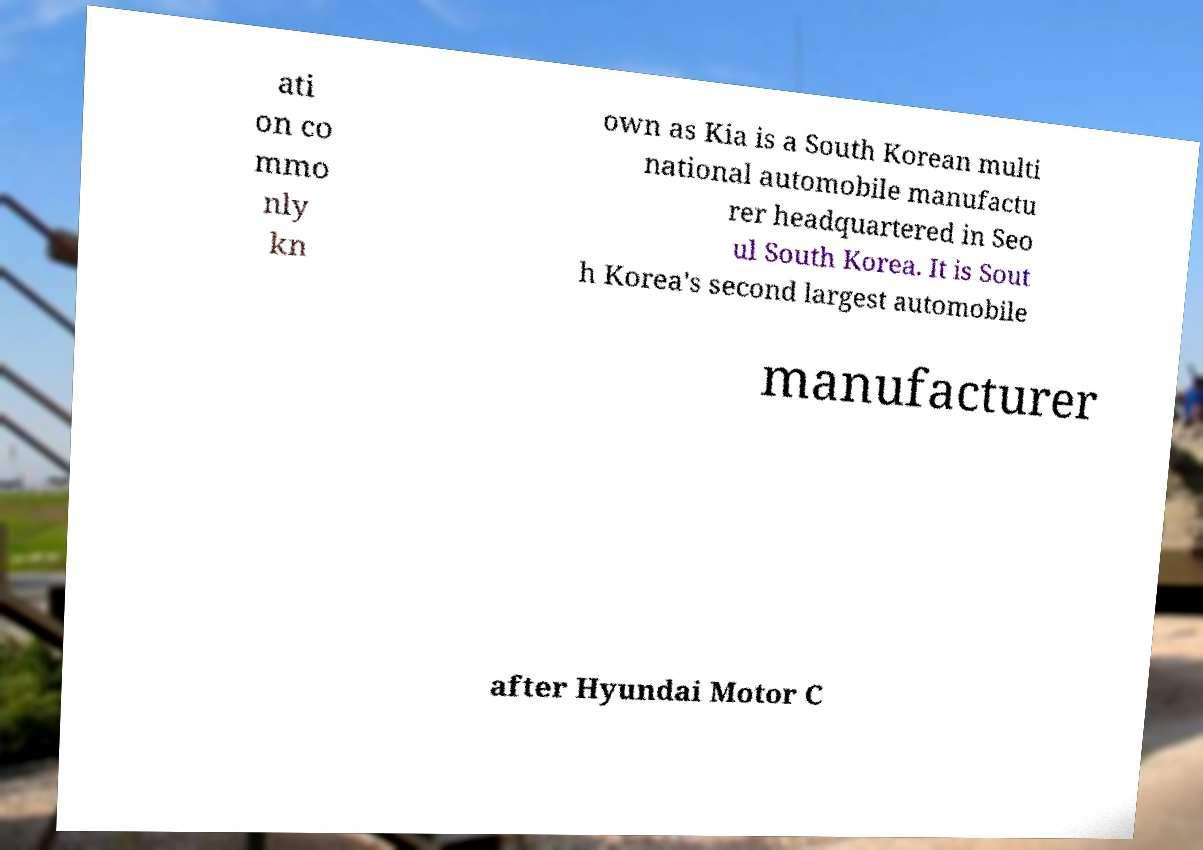Can you read and provide the text displayed in the image?This photo seems to have some interesting text. Can you extract and type it out for me? ati on co mmo nly kn own as Kia is a South Korean multi national automobile manufactu rer headquartered in Seo ul South Korea. It is Sout h Korea's second largest automobile manufacturer after Hyundai Motor C 